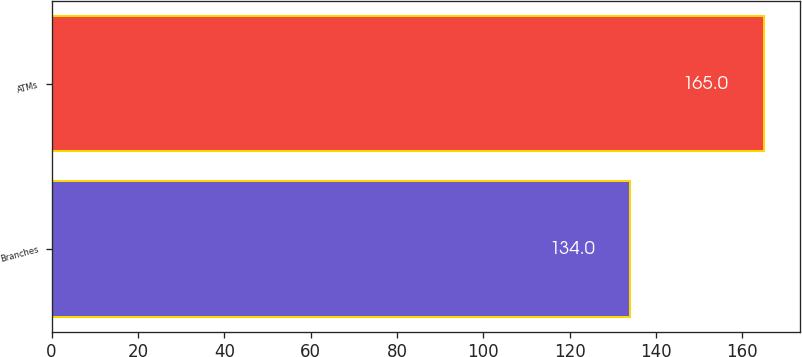<chart> <loc_0><loc_0><loc_500><loc_500><bar_chart><fcel>Branches<fcel>ATMs<nl><fcel>134<fcel>165<nl></chart> 